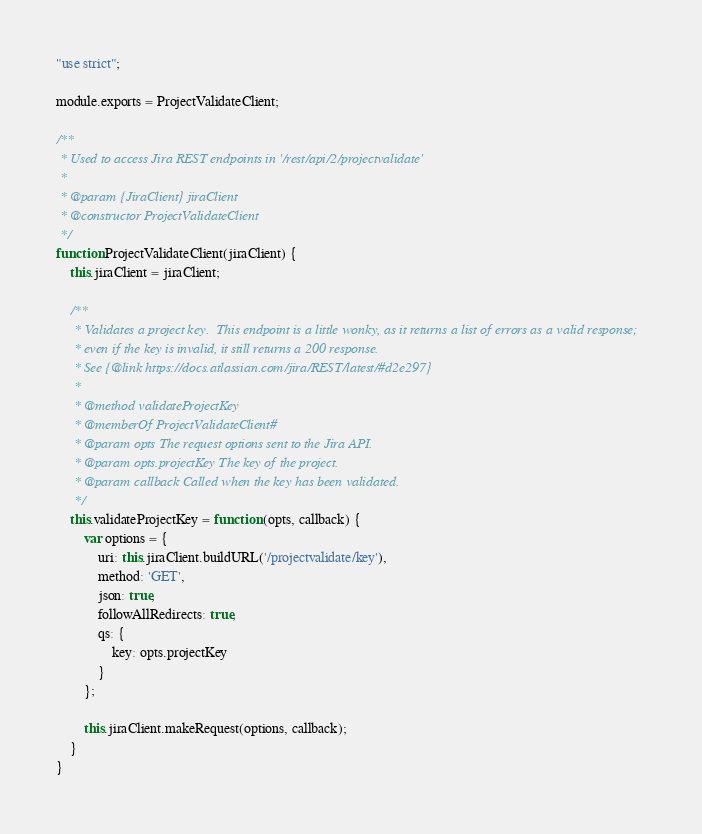Convert code to text. <code><loc_0><loc_0><loc_500><loc_500><_JavaScript_>"use strict";

module.exports = ProjectValidateClient;

/**
 * Used to access Jira REST endpoints in '/rest/api/2/projectvalidate'
 *
 * @param {JiraClient} jiraClient
 * @constructor ProjectValidateClient
 */
function ProjectValidateClient(jiraClient) {
    this.jiraClient = jiraClient;

    /**
     * Validates a project key.  This endpoint is a little wonky, as it returns a list of errors as a valid response;
     * even if the key is invalid, it still returns a 200 response.
     * See {@link https://docs.atlassian.com/jira/REST/latest/#d2e297}
     *
     * @method validateProjectKey
     * @memberOf ProjectValidateClient#
     * @param opts The request options sent to the Jira API.
     * @param opts.projectKey The key of the project.
     * @param callback Called when the key has been validated.
     */
    this.validateProjectKey = function (opts, callback) {
        var options = {
            uri: this.jiraClient.buildURL('/projectvalidate/key'),
            method: 'GET',
            json: true,
            followAllRedirects: true,
            qs: {
                key: opts.projectKey
            }
        };

        this.jiraClient.makeRequest(options, callback);
    }
}</code> 